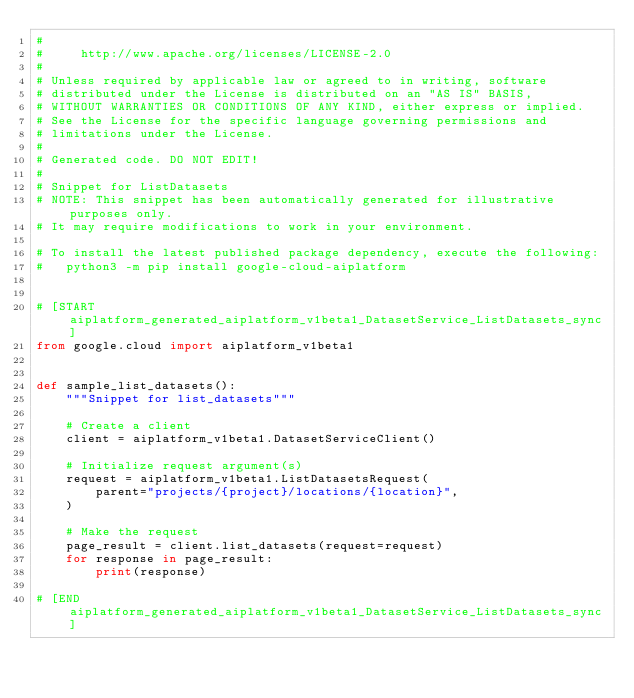Convert code to text. <code><loc_0><loc_0><loc_500><loc_500><_Python_>#
#     http://www.apache.org/licenses/LICENSE-2.0
#
# Unless required by applicable law or agreed to in writing, software
# distributed under the License is distributed on an "AS IS" BASIS,
# WITHOUT WARRANTIES OR CONDITIONS OF ANY KIND, either express or implied.
# See the License for the specific language governing permissions and
# limitations under the License.
#
# Generated code. DO NOT EDIT!
#
# Snippet for ListDatasets
# NOTE: This snippet has been automatically generated for illustrative purposes only.
# It may require modifications to work in your environment.

# To install the latest published package dependency, execute the following:
#   python3 -m pip install google-cloud-aiplatform


# [START aiplatform_generated_aiplatform_v1beta1_DatasetService_ListDatasets_sync]
from google.cloud import aiplatform_v1beta1


def sample_list_datasets():
    """Snippet for list_datasets"""

    # Create a client
    client = aiplatform_v1beta1.DatasetServiceClient()

    # Initialize request argument(s)
    request = aiplatform_v1beta1.ListDatasetsRequest(
        parent="projects/{project}/locations/{location}",
    )

    # Make the request
    page_result = client.list_datasets(request=request)
    for response in page_result:
        print(response)

# [END aiplatform_generated_aiplatform_v1beta1_DatasetService_ListDatasets_sync]
</code> 